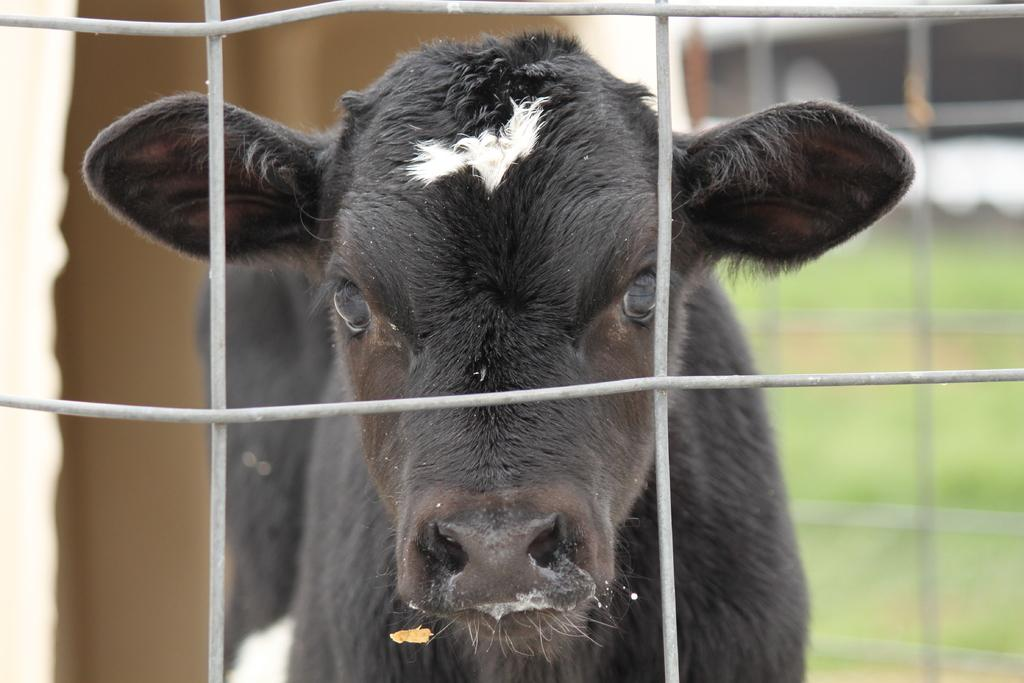What animal is present in the image? There is a cow in the image. What is the cow doing in the image? The cow is staring. What type of cap is the cow wearing in the image? There is no cap present in the image, as it features a cow staring. 